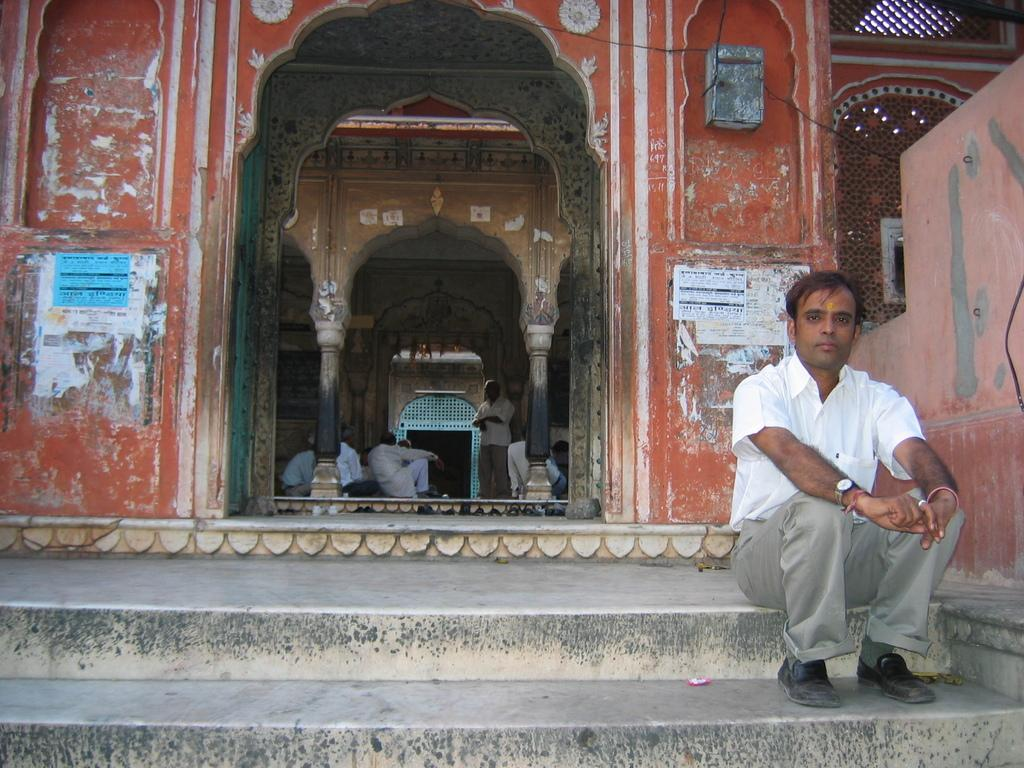What type of structure is visible in the image? There is a building in the image. Can you describe the location of the person in the image? A person is sitting on the staircase in front of the building. What is happening inside the building? There are people inside the building. What month is it in the image? The month cannot be determined from the image, as there is no information about the time of year. 